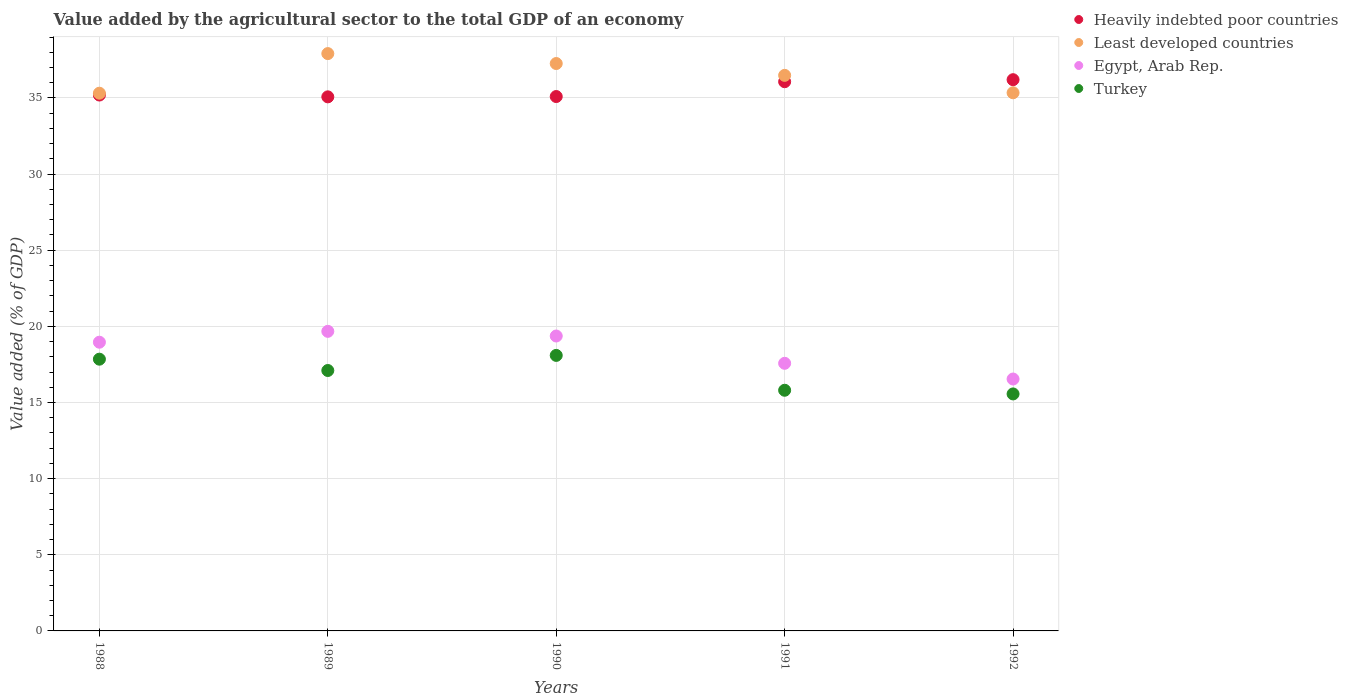How many different coloured dotlines are there?
Keep it short and to the point. 4. What is the value added by the agricultural sector to the total GDP in Least developed countries in 1992?
Give a very brief answer. 35.34. Across all years, what is the maximum value added by the agricultural sector to the total GDP in Least developed countries?
Your answer should be very brief. 37.91. Across all years, what is the minimum value added by the agricultural sector to the total GDP in Heavily indebted poor countries?
Offer a very short reply. 35.07. In which year was the value added by the agricultural sector to the total GDP in Turkey maximum?
Make the answer very short. 1990. What is the total value added by the agricultural sector to the total GDP in Heavily indebted poor countries in the graph?
Your response must be concise. 177.62. What is the difference between the value added by the agricultural sector to the total GDP in Least developed countries in 1990 and that in 1992?
Offer a terse response. 1.92. What is the difference between the value added by the agricultural sector to the total GDP in Egypt, Arab Rep. in 1989 and the value added by the agricultural sector to the total GDP in Heavily indebted poor countries in 1990?
Your answer should be very brief. -15.42. What is the average value added by the agricultural sector to the total GDP in Egypt, Arab Rep. per year?
Provide a short and direct response. 18.42. In the year 1989, what is the difference between the value added by the agricultural sector to the total GDP in Least developed countries and value added by the agricultural sector to the total GDP in Egypt, Arab Rep.?
Offer a very short reply. 18.24. In how many years, is the value added by the agricultural sector to the total GDP in Heavily indebted poor countries greater than 2 %?
Your answer should be very brief. 5. What is the ratio of the value added by the agricultural sector to the total GDP in Heavily indebted poor countries in 1988 to that in 1990?
Provide a short and direct response. 1. Is the value added by the agricultural sector to the total GDP in Turkey in 1990 less than that in 1992?
Offer a very short reply. No. What is the difference between the highest and the second highest value added by the agricultural sector to the total GDP in Heavily indebted poor countries?
Give a very brief answer. 0.13. What is the difference between the highest and the lowest value added by the agricultural sector to the total GDP in Egypt, Arab Rep.?
Your answer should be very brief. 3.13. Is the sum of the value added by the agricultural sector to the total GDP in Least developed countries in 1988 and 1990 greater than the maximum value added by the agricultural sector to the total GDP in Heavily indebted poor countries across all years?
Your answer should be compact. Yes. Is it the case that in every year, the sum of the value added by the agricultural sector to the total GDP in Egypt, Arab Rep. and value added by the agricultural sector to the total GDP in Least developed countries  is greater than the sum of value added by the agricultural sector to the total GDP in Turkey and value added by the agricultural sector to the total GDP in Heavily indebted poor countries?
Offer a terse response. Yes. Is it the case that in every year, the sum of the value added by the agricultural sector to the total GDP in Least developed countries and value added by the agricultural sector to the total GDP in Egypt, Arab Rep.  is greater than the value added by the agricultural sector to the total GDP in Turkey?
Your answer should be compact. Yes. Does the value added by the agricultural sector to the total GDP in Egypt, Arab Rep. monotonically increase over the years?
Provide a short and direct response. No. Is the value added by the agricultural sector to the total GDP in Turkey strictly less than the value added by the agricultural sector to the total GDP in Heavily indebted poor countries over the years?
Ensure brevity in your answer.  Yes. How many dotlines are there?
Your answer should be very brief. 4. What is the difference between two consecutive major ticks on the Y-axis?
Offer a terse response. 5. Are the values on the major ticks of Y-axis written in scientific E-notation?
Provide a short and direct response. No. Where does the legend appear in the graph?
Offer a very short reply. Top right. What is the title of the graph?
Provide a short and direct response. Value added by the agricultural sector to the total GDP of an economy. What is the label or title of the X-axis?
Keep it short and to the point. Years. What is the label or title of the Y-axis?
Offer a very short reply. Value added (% of GDP). What is the Value added (% of GDP) of Heavily indebted poor countries in 1988?
Ensure brevity in your answer.  35.19. What is the Value added (% of GDP) of Least developed countries in 1988?
Provide a short and direct response. 35.31. What is the Value added (% of GDP) of Egypt, Arab Rep. in 1988?
Offer a very short reply. 18.96. What is the Value added (% of GDP) in Turkey in 1988?
Make the answer very short. 17.85. What is the Value added (% of GDP) of Heavily indebted poor countries in 1989?
Ensure brevity in your answer.  35.07. What is the Value added (% of GDP) of Least developed countries in 1989?
Give a very brief answer. 37.91. What is the Value added (% of GDP) of Egypt, Arab Rep. in 1989?
Make the answer very short. 19.67. What is the Value added (% of GDP) of Turkey in 1989?
Your response must be concise. 17.1. What is the Value added (% of GDP) of Heavily indebted poor countries in 1990?
Your answer should be compact. 35.09. What is the Value added (% of GDP) in Least developed countries in 1990?
Offer a very short reply. 37.26. What is the Value added (% of GDP) of Egypt, Arab Rep. in 1990?
Your answer should be very brief. 19.37. What is the Value added (% of GDP) in Turkey in 1990?
Your answer should be very brief. 18.09. What is the Value added (% of GDP) of Heavily indebted poor countries in 1991?
Offer a terse response. 36.07. What is the Value added (% of GDP) of Least developed countries in 1991?
Ensure brevity in your answer.  36.48. What is the Value added (% of GDP) of Egypt, Arab Rep. in 1991?
Offer a very short reply. 17.57. What is the Value added (% of GDP) of Turkey in 1991?
Make the answer very short. 15.8. What is the Value added (% of GDP) in Heavily indebted poor countries in 1992?
Offer a very short reply. 36.2. What is the Value added (% of GDP) in Least developed countries in 1992?
Keep it short and to the point. 35.34. What is the Value added (% of GDP) in Egypt, Arab Rep. in 1992?
Provide a succinct answer. 16.54. What is the Value added (% of GDP) of Turkey in 1992?
Make the answer very short. 15.56. Across all years, what is the maximum Value added (% of GDP) in Heavily indebted poor countries?
Provide a succinct answer. 36.2. Across all years, what is the maximum Value added (% of GDP) of Least developed countries?
Make the answer very short. 37.91. Across all years, what is the maximum Value added (% of GDP) in Egypt, Arab Rep.?
Your answer should be compact. 19.67. Across all years, what is the maximum Value added (% of GDP) of Turkey?
Offer a very short reply. 18.09. Across all years, what is the minimum Value added (% of GDP) of Heavily indebted poor countries?
Keep it short and to the point. 35.07. Across all years, what is the minimum Value added (% of GDP) in Least developed countries?
Make the answer very short. 35.31. Across all years, what is the minimum Value added (% of GDP) in Egypt, Arab Rep.?
Ensure brevity in your answer.  16.54. Across all years, what is the minimum Value added (% of GDP) of Turkey?
Provide a succinct answer. 15.56. What is the total Value added (% of GDP) of Heavily indebted poor countries in the graph?
Your response must be concise. 177.62. What is the total Value added (% of GDP) of Least developed countries in the graph?
Your answer should be compact. 182.31. What is the total Value added (% of GDP) of Egypt, Arab Rep. in the graph?
Your answer should be compact. 92.12. What is the total Value added (% of GDP) of Turkey in the graph?
Keep it short and to the point. 84.41. What is the difference between the Value added (% of GDP) in Heavily indebted poor countries in 1988 and that in 1989?
Provide a succinct answer. 0.12. What is the difference between the Value added (% of GDP) of Least developed countries in 1988 and that in 1989?
Your response must be concise. -2.6. What is the difference between the Value added (% of GDP) of Egypt, Arab Rep. in 1988 and that in 1989?
Provide a short and direct response. -0.71. What is the difference between the Value added (% of GDP) in Turkey in 1988 and that in 1989?
Ensure brevity in your answer.  0.74. What is the difference between the Value added (% of GDP) of Heavily indebted poor countries in 1988 and that in 1990?
Make the answer very short. 0.1. What is the difference between the Value added (% of GDP) in Least developed countries in 1988 and that in 1990?
Make the answer very short. -1.95. What is the difference between the Value added (% of GDP) of Egypt, Arab Rep. in 1988 and that in 1990?
Give a very brief answer. -0.41. What is the difference between the Value added (% of GDP) in Turkey in 1988 and that in 1990?
Offer a very short reply. -0.25. What is the difference between the Value added (% of GDP) of Heavily indebted poor countries in 1988 and that in 1991?
Your answer should be very brief. -0.87. What is the difference between the Value added (% of GDP) in Least developed countries in 1988 and that in 1991?
Your response must be concise. -1.17. What is the difference between the Value added (% of GDP) of Egypt, Arab Rep. in 1988 and that in 1991?
Ensure brevity in your answer.  1.39. What is the difference between the Value added (% of GDP) of Turkey in 1988 and that in 1991?
Provide a short and direct response. 2.04. What is the difference between the Value added (% of GDP) in Heavily indebted poor countries in 1988 and that in 1992?
Your answer should be very brief. -1.01. What is the difference between the Value added (% of GDP) of Least developed countries in 1988 and that in 1992?
Make the answer very short. -0.03. What is the difference between the Value added (% of GDP) of Egypt, Arab Rep. in 1988 and that in 1992?
Your answer should be compact. 2.42. What is the difference between the Value added (% of GDP) in Turkey in 1988 and that in 1992?
Your answer should be compact. 2.28. What is the difference between the Value added (% of GDP) of Heavily indebted poor countries in 1989 and that in 1990?
Give a very brief answer. -0.02. What is the difference between the Value added (% of GDP) in Least developed countries in 1989 and that in 1990?
Your answer should be very brief. 0.65. What is the difference between the Value added (% of GDP) of Egypt, Arab Rep. in 1989 and that in 1990?
Offer a very short reply. 0.31. What is the difference between the Value added (% of GDP) in Turkey in 1989 and that in 1990?
Your answer should be compact. -0.99. What is the difference between the Value added (% of GDP) of Heavily indebted poor countries in 1989 and that in 1991?
Keep it short and to the point. -0.99. What is the difference between the Value added (% of GDP) in Least developed countries in 1989 and that in 1991?
Offer a terse response. 1.43. What is the difference between the Value added (% of GDP) in Egypt, Arab Rep. in 1989 and that in 1991?
Your answer should be very brief. 2.1. What is the difference between the Value added (% of GDP) of Turkey in 1989 and that in 1991?
Ensure brevity in your answer.  1.3. What is the difference between the Value added (% of GDP) in Heavily indebted poor countries in 1989 and that in 1992?
Give a very brief answer. -1.13. What is the difference between the Value added (% of GDP) of Least developed countries in 1989 and that in 1992?
Provide a short and direct response. 2.57. What is the difference between the Value added (% of GDP) in Egypt, Arab Rep. in 1989 and that in 1992?
Ensure brevity in your answer.  3.13. What is the difference between the Value added (% of GDP) in Turkey in 1989 and that in 1992?
Provide a succinct answer. 1.54. What is the difference between the Value added (% of GDP) in Heavily indebted poor countries in 1990 and that in 1991?
Ensure brevity in your answer.  -0.97. What is the difference between the Value added (% of GDP) of Least developed countries in 1990 and that in 1991?
Keep it short and to the point. 0.78. What is the difference between the Value added (% of GDP) of Egypt, Arab Rep. in 1990 and that in 1991?
Provide a succinct answer. 1.79. What is the difference between the Value added (% of GDP) in Turkey in 1990 and that in 1991?
Offer a very short reply. 2.29. What is the difference between the Value added (% of GDP) of Heavily indebted poor countries in 1990 and that in 1992?
Ensure brevity in your answer.  -1.11. What is the difference between the Value added (% of GDP) in Least developed countries in 1990 and that in 1992?
Offer a very short reply. 1.92. What is the difference between the Value added (% of GDP) of Egypt, Arab Rep. in 1990 and that in 1992?
Make the answer very short. 2.82. What is the difference between the Value added (% of GDP) of Turkey in 1990 and that in 1992?
Offer a terse response. 2.53. What is the difference between the Value added (% of GDP) in Heavily indebted poor countries in 1991 and that in 1992?
Provide a succinct answer. -0.13. What is the difference between the Value added (% of GDP) of Least developed countries in 1991 and that in 1992?
Your answer should be very brief. 1.14. What is the difference between the Value added (% of GDP) in Egypt, Arab Rep. in 1991 and that in 1992?
Your answer should be very brief. 1.03. What is the difference between the Value added (% of GDP) of Turkey in 1991 and that in 1992?
Offer a terse response. 0.24. What is the difference between the Value added (% of GDP) of Heavily indebted poor countries in 1988 and the Value added (% of GDP) of Least developed countries in 1989?
Give a very brief answer. -2.72. What is the difference between the Value added (% of GDP) in Heavily indebted poor countries in 1988 and the Value added (% of GDP) in Egypt, Arab Rep. in 1989?
Provide a short and direct response. 15.52. What is the difference between the Value added (% of GDP) of Heavily indebted poor countries in 1988 and the Value added (% of GDP) of Turkey in 1989?
Give a very brief answer. 18.09. What is the difference between the Value added (% of GDP) in Least developed countries in 1988 and the Value added (% of GDP) in Egypt, Arab Rep. in 1989?
Give a very brief answer. 15.64. What is the difference between the Value added (% of GDP) in Least developed countries in 1988 and the Value added (% of GDP) in Turkey in 1989?
Make the answer very short. 18.21. What is the difference between the Value added (% of GDP) of Egypt, Arab Rep. in 1988 and the Value added (% of GDP) of Turkey in 1989?
Keep it short and to the point. 1.86. What is the difference between the Value added (% of GDP) of Heavily indebted poor countries in 1988 and the Value added (% of GDP) of Least developed countries in 1990?
Your response must be concise. -2.07. What is the difference between the Value added (% of GDP) in Heavily indebted poor countries in 1988 and the Value added (% of GDP) in Egypt, Arab Rep. in 1990?
Ensure brevity in your answer.  15.82. What is the difference between the Value added (% of GDP) in Heavily indebted poor countries in 1988 and the Value added (% of GDP) in Turkey in 1990?
Give a very brief answer. 17.1. What is the difference between the Value added (% of GDP) of Least developed countries in 1988 and the Value added (% of GDP) of Egypt, Arab Rep. in 1990?
Your answer should be very brief. 15.94. What is the difference between the Value added (% of GDP) of Least developed countries in 1988 and the Value added (% of GDP) of Turkey in 1990?
Make the answer very short. 17.22. What is the difference between the Value added (% of GDP) in Egypt, Arab Rep. in 1988 and the Value added (% of GDP) in Turkey in 1990?
Offer a terse response. 0.87. What is the difference between the Value added (% of GDP) in Heavily indebted poor countries in 1988 and the Value added (% of GDP) in Least developed countries in 1991?
Ensure brevity in your answer.  -1.29. What is the difference between the Value added (% of GDP) in Heavily indebted poor countries in 1988 and the Value added (% of GDP) in Egypt, Arab Rep. in 1991?
Ensure brevity in your answer.  17.62. What is the difference between the Value added (% of GDP) of Heavily indebted poor countries in 1988 and the Value added (% of GDP) of Turkey in 1991?
Keep it short and to the point. 19.39. What is the difference between the Value added (% of GDP) of Least developed countries in 1988 and the Value added (% of GDP) of Egypt, Arab Rep. in 1991?
Provide a short and direct response. 17.74. What is the difference between the Value added (% of GDP) in Least developed countries in 1988 and the Value added (% of GDP) in Turkey in 1991?
Your answer should be very brief. 19.51. What is the difference between the Value added (% of GDP) of Egypt, Arab Rep. in 1988 and the Value added (% of GDP) of Turkey in 1991?
Your response must be concise. 3.16. What is the difference between the Value added (% of GDP) of Heavily indebted poor countries in 1988 and the Value added (% of GDP) of Least developed countries in 1992?
Make the answer very short. -0.15. What is the difference between the Value added (% of GDP) of Heavily indebted poor countries in 1988 and the Value added (% of GDP) of Egypt, Arab Rep. in 1992?
Offer a terse response. 18.65. What is the difference between the Value added (% of GDP) in Heavily indebted poor countries in 1988 and the Value added (% of GDP) in Turkey in 1992?
Ensure brevity in your answer.  19.63. What is the difference between the Value added (% of GDP) in Least developed countries in 1988 and the Value added (% of GDP) in Egypt, Arab Rep. in 1992?
Offer a very short reply. 18.77. What is the difference between the Value added (% of GDP) in Least developed countries in 1988 and the Value added (% of GDP) in Turkey in 1992?
Provide a short and direct response. 19.75. What is the difference between the Value added (% of GDP) of Egypt, Arab Rep. in 1988 and the Value added (% of GDP) of Turkey in 1992?
Make the answer very short. 3.4. What is the difference between the Value added (% of GDP) of Heavily indebted poor countries in 1989 and the Value added (% of GDP) of Least developed countries in 1990?
Your answer should be very brief. -2.19. What is the difference between the Value added (% of GDP) of Heavily indebted poor countries in 1989 and the Value added (% of GDP) of Egypt, Arab Rep. in 1990?
Keep it short and to the point. 15.71. What is the difference between the Value added (% of GDP) in Heavily indebted poor countries in 1989 and the Value added (% of GDP) in Turkey in 1990?
Offer a terse response. 16.98. What is the difference between the Value added (% of GDP) of Least developed countries in 1989 and the Value added (% of GDP) of Egypt, Arab Rep. in 1990?
Keep it short and to the point. 18.55. What is the difference between the Value added (% of GDP) in Least developed countries in 1989 and the Value added (% of GDP) in Turkey in 1990?
Offer a very short reply. 19.82. What is the difference between the Value added (% of GDP) of Egypt, Arab Rep. in 1989 and the Value added (% of GDP) of Turkey in 1990?
Provide a succinct answer. 1.58. What is the difference between the Value added (% of GDP) of Heavily indebted poor countries in 1989 and the Value added (% of GDP) of Least developed countries in 1991?
Provide a succinct answer. -1.41. What is the difference between the Value added (% of GDP) in Heavily indebted poor countries in 1989 and the Value added (% of GDP) in Egypt, Arab Rep. in 1991?
Offer a very short reply. 17.5. What is the difference between the Value added (% of GDP) of Heavily indebted poor countries in 1989 and the Value added (% of GDP) of Turkey in 1991?
Your response must be concise. 19.27. What is the difference between the Value added (% of GDP) of Least developed countries in 1989 and the Value added (% of GDP) of Egypt, Arab Rep. in 1991?
Keep it short and to the point. 20.34. What is the difference between the Value added (% of GDP) of Least developed countries in 1989 and the Value added (% of GDP) of Turkey in 1991?
Your answer should be compact. 22.11. What is the difference between the Value added (% of GDP) in Egypt, Arab Rep. in 1989 and the Value added (% of GDP) in Turkey in 1991?
Your answer should be very brief. 3.87. What is the difference between the Value added (% of GDP) in Heavily indebted poor countries in 1989 and the Value added (% of GDP) in Least developed countries in 1992?
Offer a very short reply. -0.27. What is the difference between the Value added (% of GDP) of Heavily indebted poor countries in 1989 and the Value added (% of GDP) of Egypt, Arab Rep. in 1992?
Your answer should be compact. 18.53. What is the difference between the Value added (% of GDP) in Heavily indebted poor countries in 1989 and the Value added (% of GDP) in Turkey in 1992?
Keep it short and to the point. 19.51. What is the difference between the Value added (% of GDP) in Least developed countries in 1989 and the Value added (% of GDP) in Egypt, Arab Rep. in 1992?
Provide a succinct answer. 21.37. What is the difference between the Value added (% of GDP) in Least developed countries in 1989 and the Value added (% of GDP) in Turkey in 1992?
Your response must be concise. 22.35. What is the difference between the Value added (% of GDP) in Egypt, Arab Rep. in 1989 and the Value added (% of GDP) in Turkey in 1992?
Provide a succinct answer. 4.11. What is the difference between the Value added (% of GDP) in Heavily indebted poor countries in 1990 and the Value added (% of GDP) in Least developed countries in 1991?
Make the answer very short. -1.39. What is the difference between the Value added (% of GDP) in Heavily indebted poor countries in 1990 and the Value added (% of GDP) in Egypt, Arab Rep. in 1991?
Your answer should be very brief. 17.52. What is the difference between the Value added (% of GDP) in Heavily indebted poor countries in 1990 and the Value added (% of GDP) in Turkey in 1991?
Make the answer very short. 19.29. What is the difference between the Value added (% of GDP) of Least developed countries in 1990 and the Value added (% of GDP) of Egypt, Arab Rep. in 1991?
Offer a very short reply. 19.69. What is the difference between the Value added (% of GDP) of Least developed countries in 1990 and the Value added (% of GDP) of Turkey in 1991?
Keep it short and to the point. 21.46. What is the difference between the Value added (% of GDP) in Egypt, Arab Rep. in 1990 and the Value added (% of GDP) in Turkey in 1991?
Provide a succinct answer. 3.56. What is the difference between the Value added (% of GDP) of Heavily indebted poor countries in 1990 and the Value added (% of GDP) of Least developed countries in 1992?
Provide a succinct answer. -0.25. What is the difference between the Value added (% of GDP) in Heavily indebted poor countries in 1990 and the Value added (% of GDP) in Egypt, Arab Rep. in 1992?
Your answer should be compact. 18.55. What is the difference between the Value added (% of GDP) of Heavily indebted poor countries in 1990 and the Value added (% of GDP) of Turkey in 1992?
Your response must be concise. 19.53. What is the difference between the Value added (% of GDP) of Least developed countries in 1990 and the Value added (% of GDP) of Egypt, Arab Rep. in 1992?
Make the answer very short. 20.72. What is the difference between the Value added (% of GDP) of Least developed countries in 1990 and the Value added (% of GDP) of Turkey in 1992?
Your answer should be compact. 21.7. What is the difference between the Value added (% of GDP) of Egypt, Arab Rep. in 1990 and the Value added (% of GDP) of Turkey in 1992?
Provide a succinct answer. 3.8. What is the difference between the Value added (% of GDP) in Heavily indebted poor countries in 1991 and the Value added (% of GDP) in Least developed countries in 1992?
Provide a short and direct response. 0.73. What is the difference between the Value added (% of GDP) of Heavily indebted poor countries in 1991 and the Value added (% of GDP) of Egypt, Arab Rep. in 1992?
Offer a terse response. 19.52. What is the difference between the Value added (% of GDP) in Heavily indebted poor countries in 1991 and the Value added (% of GDP) in Turkey in 1992?
Keep it short and to the point. 20.5. What is the difference between the Value added (% of GDP) of Least developed countries in 1991 and the Value added (% of GDP) of Egypt, Arab Rep. in 1992?
Your answer should be compact. 19.94. What is the difference between the Value added (% of GDP) in Least developed countries in 1991 and the Value added (% of GDP) in Turkey in 1992?
Provide a succinct answer. 20.92. What is the difference between the Value added (% of GDP) in Egypt, Arab Rep. in 1991 and the Value added (% of GDP) in Turkey in 1992?
Ensure brevity in your answer.  2.01. What is the average Value added (% of GDP) in Heavily indebted poor countries per year?
Your answer should be very brief. 35.52. What is the average Value added (% of GDP) in Least developed countries per year?
Ensure brevity in your answer.  36.46. What is the average Value added (% of GDP) in Egypt, Arab Rep. per year?
Provide a short and direct response. 18.42. What is the average Value added (% of GDP) of Turkey per year?
Give a very brief answer. 16.88. In the year 1988, what is the difference between the Value added (% of GDP) of Heavily indebted poor countries and Value added (% of GDP) of Least developed countries?
Provide a short and direct response. -0.12. In the year 1988, what is the difference between the Value added (% of GDP) in Heavily indebted poor countries and Value added (% of GDP) in Egypt, Arab Rep.?
Make the answer very short. 16.23. In the year 1988, what is the difference between the Value added (% of GDP) of Heavily indebted poor countries and Value added (% of GDP) of Turkey?
Your answer should be very brief. 17.35. In the year 1988, what is the difference between the Value added (% of GDP) in Least developed countries and Value added (% of GDP) in Egypt, Arab Rep.?
Make the answer very short. 16.35. In the year 1988, what is the difference between the Value added (% of GDP) in Least developed countries and Value added (% of GDP) in Turkey?
Ensure brevity in your answer.  17.47. In the year 1988, what is the difference between the Value added (% of GDP) of Egypt, Arab Rep. and Value added (% of GDP) of Turkey?
Your answer should be compact. 1.11. In the year 1989, what is the difference between the Value added (% of GDP) of Heavily indebted poor countries and Value added (% of GDP) of Least developed countries?
Your answer should be compact. -2.84. In the year 1989, what is the difference between the Value added (% of GDP) in Heavily indebted poor countries and Value added (% of GDP) in Egypt, Arab Rep.?
Provide a succinct answer. 15.4. In the year 1989, what is the difference between the Value added (% of GDP) in Heavily indebted poor countries and Value added (% of GDP) in Turkey?
Your response must be concise. 17.97. In the year 1989, what is the difference between the Value added (% of GDP) of Least developed countries and Value added (% of GDP) of Egypt, Arab Rep.?
Keep it short and to the point. 18.24. In the year 1989, what is the difference between the Value added (% of GDP) in Least developed countries and Value added (% of GDP) in Turkey?
Offer a terse response. 20.81. In the year 1989, what is the difference between the Value added (% of GDP) in Egypt, Arab Rep. and Value added (% of GDP) in Turkey?
Ensure brevity in your answer.  2.57. In the year 1990, what is the difference between the Value added (% of GDP) of Heavily indebted poor countries and Value added (% of GDP) of Least developed countries?
Offer a very short reply. -2.17. In the year 1990, what is the difference between the Value added (% of GDP) in Heavily indebted poor countries and Value added (% of GDP) in Egypt, Arab Rep.?
Keep it short and to the point. 15.73. In the year 1990, what is the difference between the Value added (% of GDP) of Heavily indebted poor countries and Value added (% of GDP) of Turkey?
Make the answer very short. 17. In the year 1990, what is the difference between the Value added (% of GDP) in Least developed countries and Value added (% of GDP) in Egypt, Arab Rep.?
Provide a short and direct response. 17.89. In the year 1990, what is the difference between the Value added (% of GDP) of Least developed countries and Value added (% of GDP) of Turkey?
Provide a succinct answer. 19.17. In the year 1990, what is the difference between the Value added (% of GDP) of Egypt, Arab Rep. and Value added (% of GDP) of Turkey?
Offer a terse response. 1.27. In the year 1991, what is the difference between the Value added (% of GDP) of Heavily indebted poor countries and Value added (% of GDP) of Least developed countries?
Give a very brief answer. -0.42. In the year 1991, what is the difference between the Value added (% of GDP) in Heavily indebted poor countries and Value added (% of GDP) in Egypt, Arab Rep.?
Ensure brevity in your answer.  18.49. In the year 1991, what is the difference between the Value added (% of GDP) in Heavily indebted poor countries and Value added (% of GDP) in Turkey?
Ensure brevity in your answer.  20.26. In the year 1991, what is the difference between the Value added (% of GDP) in Least developed countries and Value added (% of GDP) in Egypt, Arab Rep.?
Give a very brief answer. 18.91. In the year 1991, what is the difference between the Value added (% of GDP) in Least developed countries and Value added (% of GDP) in Turkey?
Keep it short and to the point. 20.68. In the year 1991, what is the difference between the Value added (% of GDP) in Egypt, Arab Rep. and Value added (% of GDP) in Turkey?
Make the answer very short. 1.77. In the year 1992, what is the difference between the Value added (% of GDP) in Heavily indebted poor countries and Value added (% of GDP) in Least developed countries?
Provide a succinct answer. 0.86. In the year 1992, what is the difference between the Value added (% of GDP) in Heavily indebted poor countries and Value added (% of GDP) in Egypt, Arab Rep.?
Offer a very short reply. 19.66. In the year 1992, what is the difference between the Value added (% of GDP) of Heavily indebted poor countries and Value added (% of GDP) of Turkey?
Your answer should be very brief. 20.64. In the year 1992, what is the difference between the Value added (% of GDP) of Least developed countries and Value added (% of GDP) of Egypt, Arab Rep.?
Your answer should be very brief. 18.8. In the year 1992, what is the difference between the Value added (% of GDP) in Least developed countries and Value added (% of GDP) in Turkey?
Make the answer very short. 19.78. In the year 1992, what is the difference between the Value added (% of GDP) of Egypt, Arab Rep. and Value added (% of GDP) of Turkey?
Make the answer very short. 0.98. What is the ratio of the Value added (% of GDP) of Least developed countries in 1988 to that in 1989?
Provide a short and direct response. 0.93. What is the ratio of the Value added (% of GDP) in Egypt, Arab Rep. in 1988 to that in 1989?
Keep it short and to the point. 0.96. What is the ratio of the Value added (% of GDP) of Turkey in 1988 to that in 1989?
Keep it short and to the point. 1.04. What is the ratio of the Value added (% of GDP) of Least developed countries in 1988 to that in 1990?
Your answer should be compact. 0.95. What is the ratio of the Value added (% of GDP) of Turkey in 1988 to that in 1990?
Make the answer very short. 0.99. What is the ratio of the Value added (% of GDP) of Heavily indebted poor countries in 1988 to that in 1991?
Your answer should be compact. 0.98. What is the ratio of the Value added (% of GDP) in Least developed countries in 1988 to that in 1991?
Keep it short and to the point. 0.97. What is the ratio of the Value added (% of GDP) in Egypt, Arab Rep. in 1988 to that in 1991?
Your answer should be compact. 1.08. What is the ratio of the Value added (% of GDP) of Turkey in 1988 to that in 1991?
Give a very brief answer. 1.13. What is the ratio of the Value added (% of GDP) in Heavily indebted poor countries in 1988 to that in 1992?
Offer a terse response. 0.97. What is the ratio of the Value added (% of GDP) in Egypt, Arab Rep. in 1988 to that in 1992?
Provide a short and direct response. 1.15. What is the ratio of the Value added (% of GDP) in Turkey in 1988 to that in 1992?
Offer a terse response. 1.15. What is the ratio of the Value added (% of GDP) of Heavily indebted poor countries in 1989 to that in 1990?
Your answer should be compact. 1. What is the ratio of the Value added (% of GDP) in Least developed countries in 1989 to that in 1990?
Ensure brevity in your answer.  1.02. What is the ratio of the Value added (% of GDP) of Egypt, Arab Rep. in 1989 to that in 1990?
Make the answer very short. 1.02. What is the ratio of the Value added (% of GDP) in Turkey in 1989 to that in 1990?
Make the answer very short. 0.95. What is the ratio of the Value added (% of GDP) in Heavily indebted poor countries in 1989 to that in 1991?
Offer a terse response. 0.97. What is the ratio of the Value added (% of GDP) of Least developed countries in 1989 to that in 1991?
Your answer should be compact. 1.04. What is the ratio of the Value added (% of GDP) in Egypt, Arab Rep. in 1989 to that in 1991?
Make the answer very short. 1.12. What is the ratio of the Value added (% of GDP) in Turkey in 1989 to that in 1991?
Provide a short and direct response. 1.08. What is the ratio of the Value added (% of GDP) of Heavily indebted poor countries in 1989 to that in 1992?
Provide a succinct answer. 0.97. What is the ratio of the Value added (% of GDP) in Least developed countries in 1989 to that in 1992?
Offer a very short reply. 1.07. What is the ratio of the Value added (% of GDP) of Egypt, Arab Rep. in 1989 to that in 1992?
Your response must be concise. 1.19. What is the ratio of the Value added (% of GDP) of Turkey in 1989 to that in 1992?
Your answer should be compact. 1.1. What is the ratio of the Value added (% of GDP) of Least developed countries in 1990 to that in 1991?
Ensure brevity in your answer.  1.02. What is the ratio of the Value added (% of GDP) in Egypt, Arab Rep. in 1990 to that in 1991?
Offer a terse response. 1.1. What is the ratio of the Value added (% of GDP) of Turkey in 1990 to that in 1991?
Your response must be concise. 1.14. What is the ratio of the Value added (% of GDP) in Heavily indebted poor countries in 1990 to that in 1992?
Provide a short and direct response. 0.97. What is the ratio of the Value added (% of GDP) of Least developed countries in 1990 to that in 1992?
Give a very brief answer. 1.05. What is the ratio of the Value added (% of GDP) of Egypt, Arab Rep. in 1990 to that in 1992?
Your response must be concise. 1.17. What is the ratio of the Value added (% of GDP) of Turkey in 1990 to that in 1992?
Give a very brief answer. 1.16. What is the ratio of the Value added (% of GDP) of Least developed countries in 1991 to that in 1992?
Your response must be concise. 1.03. What is the ratio of the Value added (% of GDP) in Egypt, Arab Rep. in 1991 to that in 1992?
Keep it short and to the point. 1.06. What is the ratio of the Value added (% of GDP) in Turkey in 1991 to that in 1992?
Offer a terse response. 1.02. What is the difference between the highest and the second highest Value added (% of GDP) in Heavily indebted poor countries?
Ensure brevity in your answer.  0.13. What is the difference between the highest and the second highest Value added (% of GDP) of Least developed countries?
Keep it short and to the point. 0.65. What is the difference between the highest and the second highest Value added (% of GDP) of Egypt, Arab Rep.?
Give a very brief answer. 0.31. What is the difference between the highest and the second highest Value added (% of GDP) in Turkey?
Offer a terse response. 0.25. What is the difference between the highest and the lowest Value added (% of GDP) in Heavily indebted poor countries?
Ensure brevity in your answer.  1.13. What is the difference between the highest and the lowest Value added (% of GDP) of Least developed countries?
Provide a short and direct response. 2.6. What is the difference between the highest and the lowest Value added (% of GDP) of Egypt, Arab Rep.?
Make the answer very short. 3.13. What is the difference between the highest and the lowest Value added (% of GDP) of Turkey?
Offer a very short reply. 2.53. 